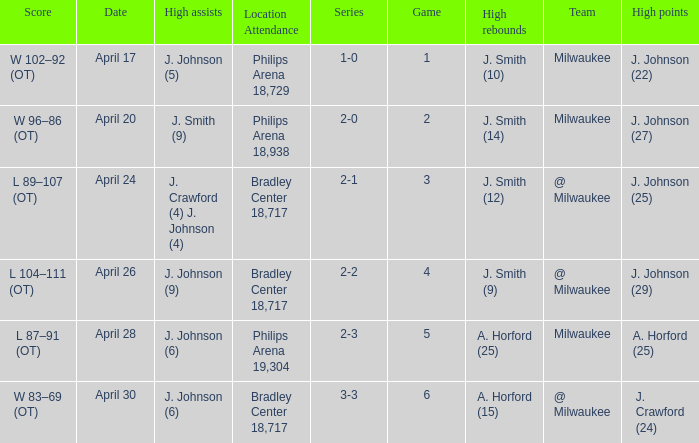What were the amount of rebounds in game 2? J. Smith (14). 